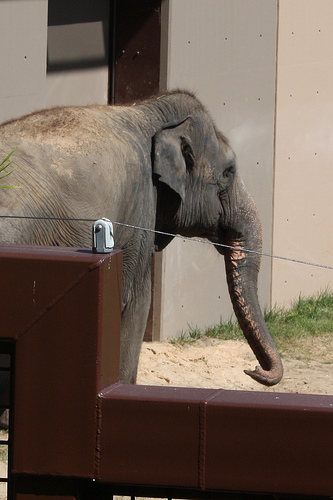<image>
Can you confirm if the elephant is behind the building? No. The elephant is not behind the building. From this viewpoint, the elephant appears to be positioned elsewhere in the scene. Is the elephant in front of the wire? Yes. The elephant is positioned in front of the wire, appearing closer to the camera viewpoint. 